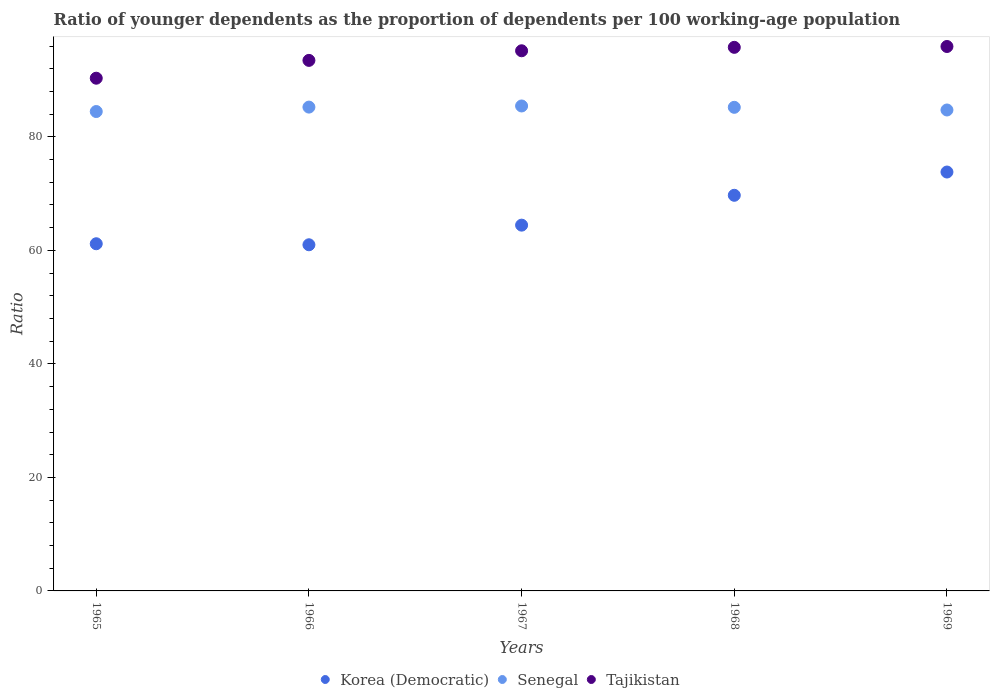Is the number of dotlines equal to the number of legend labels?
Your answer should be very brief. Yes. What is the age dependency ratio(young) in Senegal in 1969?
Keep it short and to the point. 84.74. Across all years, what is the maximum age dependency ratio(young) in Korea (Democratic)?
Make the answer very short. 73.81. Across all years, what is the minimum age dependency ratio(young) in Tajikistan?
Ensure brevity in your answer.  90.34. In which year was the age dependency ratio(young) in Senegal maximum?
Offer a very short reply. 1967. In which year was the age dependency ratio(young) in Korea (Democratic) minimum?
Ensure brevity in your answer.  1966. What is the total age dependency ratio(young) in Tajikistan in the graph?
Offer a very short reply. 470.68. What is the difference between the age dependency ratio(young) in Senegal in 1965 and that in 1969?
Offer a very short reply. -0.27. What is the difference between the age dependency ratio(young) in Senegal in 1969 and the age dependency ratio(young) in Korea (Democratic) in 1968?
Your response must be concise. 15.03. What is the average age dependency ratio(young) in Korea (Democratic) per year?
Make the answer very short. 66.02. In the year 1967, what is the difference between the age dependency ratio(young) in Tajikistan and age dependency ratio(young) in Senegal?
Your response must be concise. 9.73. In how many years, is the age dependency ratio(young) in Senegal greater than 76?
Keep it short and to the point. 5. What is the ratio of the age dependency ratio(young) in Senegal in 1967 to that in 1968?
Offer a very short reply. 1. Is the age dependency ratio(young) in Tajikistan in 1965 less than that in 1967?
Keep it short and to the point. Yes. What is the difference between the highest and the second highest age dependency ratio(young) in Senegal?
Provide a succinct answer. 0.2. What is the difference between the highest and the lowest age dependency ratio(young) in Senegal?
Your answer should be very brief. 0.98. In how many years, is the age dependency ratio(young) in Tajikistan greater than the average age dependency ratio(young) in Tajikistan taken over all years?
Your answer should be very brief. 3. Is the sum of the age dependency ratio(young) in Senegal in 1965 and 1968 greater than the maximum age dependency ratio(young) in Korea (Democratic) across all years?
Make the answer very short. Yes. Does the age dependency ratio(young) in Korea (Democratic) monotonically increase over the years?
Ensure brevity in your answer.  No. How many dotlines are there?
Your answer should be compact. 3. How many years are there in the graph?
Your answer should be compact. 5. What is the difference between two consecutive major ticks on the Y-axis?
Give a very brief answer. 20. Does the graph contain any zero values?
Keep it short and to the point. No. How many legend labels are there?
Provide a short and direct response. 3. What is the title of the graph?
Offer a very short reply. Ratio of younger dependents as the proportion of dependents per 100 working-age population. What is the label or title of the Y-axis?
Ensure brevity in your answer.  Ratio. What is the Ratio in Korea (Democratic) in 1965?
Provide a succinct answer. 61.17. What is the Ratio in Senegal in 1965?
Ensure brevity in your answer.  84.47. What is the Ratio of Tajikistan in 1965?
Keep it short and to the point. 90.34. What is the Ratio of Korea (Democratic) in 1966?
Provide a succinct answer. 60.99. What is the Ratio of Senegal in 1966?
Provide a succinct answer. 85.24. What is the Ratio of Tajikistan in 1966?
Your answer should be compact. 93.48. What is the Ratio in Korea (Democratic) in 1967?
Your answer should be very brief. 64.45. What is the Ratio of Senegal in 1967?
Your response must be concise. 85.44. What is the Ratio in Tajikistan in 1967?
Provide a succinct answer. 95.17. What is the Ratio in Korea (Democratic) in 1968?
Your answer should be compact. 69.71. What is the Ratio of Senegal in 1968?
Your answer should be compact. 85.21. What is the Ratio of Tajikistan in 1968?
Your answer should be very brief. 95.77. What is the Ratio of Korea (Democratic) in 1969?
Give a very brief answer. 73.81. What is the Ratio of Senegal in 1969?
Offer a very short reply. 84.74. What is the Ratio of Tajikistan in 1969?
Keep it short and to the point. 95.92. Across all years, what is the maximum Ratio in Korea (Democratic)?
Make the answer very short. 73.81. Across all years, what is the maximum Ratio in Senegal?
Ensure brevity in your answer.  85.44. Across all years, what is the maximum Ratio in Tajikistan?
Your answer should be compact. 95.92. Across all years, what is the minimum Ratio in Korea (Democratic)?
Provide a short and direct response. 60.99. Across all years, what is the minimum Ratio of Senegal?
Provide a short and direct response. 84.47. Across all years, what is the minimum Ratio of Tajikistan?
Keep it short and to the point. 90.34. What is the total Ratio in Korea (Democratic) in the graph?
Offer a terse response. 330.12. What is the total Ratio of Senegal in the graph?
Your response must be concise. 425.1. What is the total Ratio of Tajikistan in the graph?
Your answer should be compact. 470.68. What is the difference between the Ratio of Korea (Democratic) in 1965 and that in 1966?
Keep it short and to the point. 0.18. What is the difference between the Ratio of Senegal in 1965 and that in 1966?
Your response must be concise. -0.78. What is the difference between the Ratio in Tajikistan in 1965 and that in 1966?
Give a very brief answer. -3.14. What is the difference between the Ratio of Korea (Democratic) in 1965 and that in 1967?
Your answer should be compact. -3.28. What is the difference between the Ratio of Senegal in 1965 and that in 1967?
Provide a succinct answer. -0.98. What is the difference between the Ratio of Tajikistan in 1965 and that in 1967?
Your answer should be very brief. -4.83. What is the difference between the Ratio of Korea (Democratic) in 1965 and that in 1968?
Your response must be concise. -8.54. What is the difference between the Ratio in Senegal in 1965 and that in 1968?
Offer a very short reply. -0.74. What is the difference between the Ratio in Tajikistan in 1965 and that in 1968?
Offer a very short reply. -5.44. What is the difference between the Ratio in Korea (Democratic) in 1965 and that in 1969?
Keep it short and to the point. -12.64. What is the difference between the Ratio in Senegal in 1965 and that in 1969?
Your answer should be compact. -0.27. What is the difference between the Ratio of Tajikistan in 1965 and that in 1969?
Offer a very short reply. -5.59. What is the difference between the Ratio in Korea (Democratic) in 1966 and that in 1967?
Make the answer very short. -3.46. What is the difference between the Ratio in Senegal in 1966 and that in 1967?
Offer a very short reply. -0.2. What is the difference between the Ratio of Tajikistan in 1966 and that in 1967?
Offer a very short reply. -1.69. What is the difference between the Ratio in Korea (Democratic) in 1966 and that in 1968?
Keep it short and to the point. -8.72. What is the difference between the Ratio in Senegal in 1966 and that in 1968?
Ensure brevity in your answer.  0.04. What is the difference between the Ratio of Tajikistan in 1966 and that in 1968?
Keep it short and to the point. -2.3. What is the difference between the Ratio in Korea (Democratic) in 1966 and that in 1969?
Offer a terse response. -12.82. What is the difference between the Ratio of Senegal in 1966 and that in 1969?
Provide a succinct answer. 0.51. What is the difference between the Ratio in Tajikistan in 1966 and that in 1969?
Give a very brief answer. -2.45. What is the difference between the Ratio in Korea (Democratic) in 1967 and that in 1968?
Keep it short and to the point. -5.26. What is the difference between the Ratio in Senegal in 1967 and that in 1968?
Your response must be concise. 0.24. What is the difference between the Ratio of Tajikistan in 1967 and that in 1968?
Your answer should be very brief. -0.61. What is the difference between the Ratio in Korea (Democratic) in 1967 and that in 1969?
Offer a very short reply. -9.36. What is the difference between the Ratio in Senegal in 1967 and that in 1969?
Offer a terse response. 0.71. What is the difference between the Ratio in Tajikistan in 1967 and that in 1969?
Provide a succinct answer. -0.76. What is the difference between the Ratio in Korea (Democratic) in 1968 and that in 1969?
Provide a short and direct response. -4.1. What is the difference between the Ratio in Senegal in 1968 and that in 1969?
Keep it short and to the point. 0.47. What is the difference between the Ratio of Tajikistan in 1968 and that in 1969?
Your response must be concise. -0.15. What is the difference between the Ratio of Korea (Democratic) in 1965 and the Ratio of Senegal in 1966?
Give a very brief answer. -24.08. What is the difference between the Ratio of Korea (Democratic) in 1965 and the Ratio of Tajikistan in 1966?
Offer a terse response. -32.31. What is the difference between the Ratio of Senegal in 1965 and the Ratio of Tajikistan in 1966?
Give a very brief answer. -9.01. What is the difference between the Ratio of Korea (Democratic) in 1965 and the Ratio of Senegal in 1967?
Make the answer very short. -24.27. What is the difference between the Ratio of Korea (Democratic) in 1965 and the Ratio of Tajikistan in 1967?
Give a very brief answer. -34. What is the difference between the Ratio of Senegal in 1965 and the Ratio of Tajikistan in 1967?
Keep it short and to the point. -10.7. What is the difference between the Ratio of Korea (Democratic) in 1965 and the Ratio of Senegal in 1968?
Your answer should be compact. -24.04. What is the difference between the Ratio of Korea (Democratic) in 1965 and the Ratio of Tajikistan in 1968?
Your answer should be compact. -34.61. What is the difference between the Ratio of Senegal in 1965 and the Ratio of Tajikistan in 1968?
Your response must be concise. -11.31. What is the difference between the Ratio in Korea (Democratic) in 1965 and the Ratio in Senegal in 1969?
Offer a very short reply. -23.57. What is the difference between the Ratio in Korea (Democratic) in 1965 and the Ratio in Tajikistan in 1969?
Offer a very short reply. -34.76. What is the difference between the Ratio in Senegal in 1965 and the Ratio in Tajikistan in 1969?
Give a very brief answer. -11.46. What is the difference between the Ratio of Korea (Democratic) in 1966 and the Ratio of Senegal in 1967?
Provide a short and direct response. -24.45. What is the difference between the Ratio in Korea (Democratic) in 1966 and the Ratio in Tajikistan in 1967?
Make the answer very short. -34.18. What is the difference between the Ratio in Senegal in 1966 and the Ratio in Tajikistan in 1967?
Offer a terse response. -9.92. What is the difference between the Ratio in Korea (Democratic) in 1966 and the Ratio in Senegal in 1968?
Provide a succinct answer. -24.22. What is the difference between the Ratio in Korea (Democratic) in 1966 and the Ratio in Tajikistan in 1968?
Your response must be concise. -34.79. What is the difference between the Ratio of Senegal in 1966 and the Ratio of Tajikistan in 1968?
Keep it short and to the point. -10.53. What is the difference between the Ratio of Korea (Democratic) in 1966 and the Ratio of Senegal in 1969?
Your answer should be compact. -23.75. What is the difference between the Ratio in Korea (Democratic) in 1966 and the Ratio in Tajikistan in 1969?
Your answer should be compact. -34.94. What is the difference between the Ratio of Senegal in 1966 and the Ratio of Tajikistan in 1969?
Your response must be concise. -10.68. What is the difference between the Ratio in Korea (Democratic) in 1967 and the Ratio in Senegal in 1968?
Your answer should be very brief. -20.76. What is the difference between the Ratio of Korea (Democratic) in 1967 and the Ratio of Tajikistan in 1968?
Provide a short and direct response. -31.33. What is the difference between the Ratio in Senegal in 1967 and the Ratio in Tajikistan in 1968?
Your answer should be compact. -10.33. What is the difference between the Ratio in Korea (Democratic) in 1967 and the Ratio in Senegal in 1969?
Ensure brevity in your answer.  -20.29. What is the difference between the Ratio of Korea (Democratic) in 1967 and the Ratio of Tajikistan in 1969?
Provide a succinct answer. -31.48. What is the difference between the Ratio of Senegal in 1967 and the Ratio of Tajikistan in 1969?
Provide a short and direct response. -10.48. What is the difference between the Ratio of Korea (Democratic) in 1968 and the Ratio of Senegal in 1969?
Ensure brevity in your answer.  -15.03. What is the difference between the Ratio in Korea (Democratic) in 1968 and the Ratio in Tajikistan in 1969?
Provide a succinct answer. -26.22. What is the difference between the Ratio in Senegal in 1968 and the Ratio in Tajikistan in 1969?
Keep it short and to the point. -10.72. What is the average Ratio of Korea (Democratic) per year?
Offer a terse response. 66.02. What is the average Ratio of Senegal per year?
Provide a succinct answer. 85.02. What is the average Ratio of Tajikistan per year?
Your response must be concise. 94.14. In the year 1965, what is the difference between the Ratio of Korea (Democratic) and Ratio of Senegal?
Offer a very short reply. -23.3. In the year 1965, what is the difference between the Ratio in Korea (Democratic) and Ratio in Tajikistan?
Provide a short and direct response. -29.17. In the year 1965, what is the difference between the Ratio of Senegal and Ratio of Tajikistan?
Your answer should be compact. -5.87. In the year 1966, what is the difference between the Ratio of Korea (Democratic) and Ratio of Senegal?
Give a very brief answer. -24.26. In the year 1966, what is the difference between the Ratio in Korea (Democratic) and Ratio in Tajikistan?
Make the answer very short. -32.49. In the year 1966, what is the difference between the Ratio in Senegal and Ratio in Tajikistan?
Provide a short and direct response. -8.23. In the year 1967, what is the difference between the Ratio of Korea (Democratic) and Ratio of Senegal?
Give a very brief answer. -21. In the year 1967, what is the difference between the Ratio in Korea (Democratic) and Ratio in Tajikistan?
Ensure brevity in your answer.  -30.72. In the year 1967, what is the difference between the Ratio in Senegal and Ratio in Tajikistan?
Offer a terse response. -9.73. In the year 1968, what is the difference between the Ratio of Korea (Democratic) and Ratio of Senegal?
Your response must be concise. -15.5. In the year 1968, what is the difference between the Ratio in Korea (Democratic) and Ratio in Tajikistan?
Provide a short and direct response. -26.07. In the year 1968, what is the difference between the Ratio in Senegal and Ratio in Tajikistan?
Offer a very short reply. -10.57. In the year 1969, what is the difference between the Ratio of Korea (Democratic) and Ratio of Senegal?
Provide a succinct answer. -10.93. In the year 1969, what is the difference between the Ratio in Korea (Democratic) and Ratio in Tajikistan?
Your answer should be compact. -22.12. In the year 1969, what is the difference between the Ratio in Senegal and Ratio in Tajikistan?
Keep it short and to the point. -11.19. What is the ratio of the Ratio of Senegal in 1965 to that in 1966?
Make the answer very short. 0.99. What is the ratio of the Ratio of Tajikistan in 1965 to that in 1966?
Make the answer very short. 0.97. What is the ratio of the Ratio of Korea (Democratic) in 1965 to that in 1967?
Offer a terse response. 0.95. What is the ratio of the Ratio of Tajikistan in 1965 to that in 1967?
Ensure brevity in your answer.  0.95. What is the ratio of the Ratio in Korea (Democratic) in 1965 to that in 1968?
Your answer should be very brief. 0.88. What is the ratio of the Ratio in Senegal in 1965 to that in 1968?
Give a very brief answer. 0.99. What is the ratio of the Ratio of Tajikistan in 1965 to that in 1968?
Your answer should be very brief. 0.94. What is the ratio of the Ratio of Korea (Democratic) in 1965 to that in 1969?
Make the answer very short. 0.83. What is the ratio of the Ratio in Senegal in 1965 to that in 1969?
Your response must be concise. 1. What is the ratio of the Ratio in Tajikistan in 1965 to that in 1969?
Provide a succinct answer. 0.94. What is the ratio of the Ratio in Korea (Democratic) in 1966 to that in 1967?
Offer a terse response. 0.95. What is the ratio of the Ratio in Tajikistan in 1966 to that in 1967?
Your answer should be compact. 0.98. What is the ratio of the Ratio in Korea (Democratic) in 1966 to that in 1968?
Keep it short and to the point. 0.87. What is the ratio of the Ratio in Senegal in 1966 to that in 1968?
Your response must be concise. 1. What is the ratio of the Ratio of Korea (Democratic) in 1966 to that in 1969?
Your response must be concise. 0.83. What is the ratio of the Ratio of Senegal in 1966 to that in 1969?
Provide a succinct answer. 1.01. What is the ratio of the Ratio of Tajikistan in 1966 to that in 1969?
Make the answer very short. 0.97. What is the ratio of the Ratio of Korea (Democratic) in 1967 to that in 1968?
Your response must be concise. 0.92. What is the ratio of the Ratio in Senegal in 1967 to that in 1968?
Your answer should be compact. 1. What is the ratio of the Ratio in Korea (Democratic) in 1967 to that in 1969?
Offer a terse response. 0.87. What is the ratio of the Ratio in Senegal in 1967 to that in 1969?
Ensure brevity in your answer.  1.01. What is the ratio of the Ratio in Korea (Democratic) in 1968 to that in 1969?
Provide a short and direct response. 0.94. What is the ratio of the Ratio in Tajikistan in 1968 to that in 1969?
Ensure brevity in your answer.  1. What is the difference between the highest and the second highest Ratio of Korea (Democratic)?
Provide a succinct answer. 4.1. What is the difference between the highest and the second highest Ratio in Senegal?
Offer a very short reply. 0.2. What is the difference between the highest and the second highest Ratio of Tajikistan?
Your response must be concise. 0.15. What is the difference between the highest and the lowest Ratio in Korea (Democratic)?
Keep it short and to the point. 12.82. What is the difference between the highest and the lowest Ratio of Senegal?
Offer a very short reply. 0.98. What is the difference between the highest and the lowest Ratio of Tajikistan?
Your answer should be compact. 5.59. 